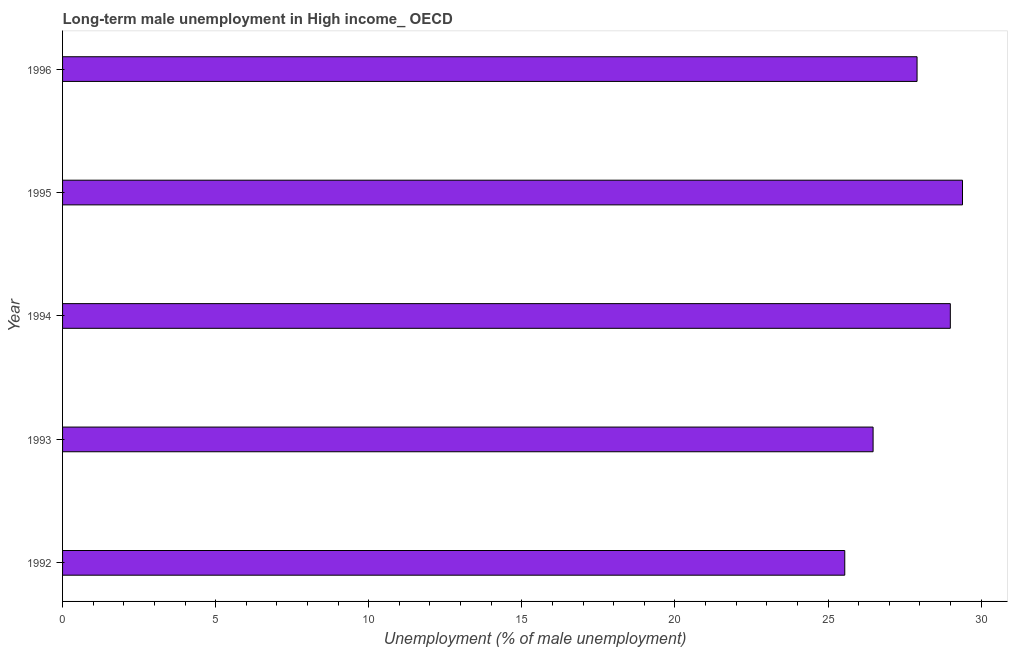What is the title of the graph?
Your response must be concise. Long-term male unemployment in High income_ OECD. What is the label or title of the X-axis?
Provide a succinct answer. Unemployment (% of male unemployment). What is the long-term male unemployment in 1993?
Offer a very short reply. 26.47. Across all years, what is the maximum long-term male unemployment?
Your answer should be compact. 29.39. Across all years, what is the minimum long-term male unemployment?
Give a very brief answer. 25.55. In which year was the long-term male unemployment maximum?
Your response must be concise. 1995. In which year was the long-term male unemployment minimum?
Make the answer very short. 1992. What is the sum of the long-term male unemployment?
Ensure brevity in your answer.  138.31. What is the difference between the long-term male unemployment in 1993 and 1994?
Make the answer very short. -2.52. What is the average long-term male unemployment per year?
Your answer should be very brief. 27.66. What is the median long-term male unemployment?
Offer a terse response. 27.91. Do a majority of the years between 1995 and 1996 (inclusive) have long-term male unemployment greater than 21 %?
Your answer should be compact. Yes. Is the difference between the long-term male unemployment in 1992 and 1996 greater than the difference between any two years?
Ensure brevity in your answer.  No. What is the difference between the highest and the second highest long-term male unemployment?
Offer a very short reply. 0.4. What is the difference between the highest and the lowest long-term male unemployment?
Make the answer very short. 3.85. In how many years, is the long-term male unemployment greater than the average long-term male unemployment taken over all years?
Give a very brief answer. 3. What is the difference between two consecutive major ticks on the X-axis?
Your response must be concise. 5. Are the values on the major ticks of X-axis written in scientific E-notation?
Provide a short and direct response. No. What is the Unemployment (% of male unemployment) of 1992?
Your answer should be very brief. 25.55. What is the Unemployment (% of male unemployment) of 1993?
Keep it short and to the point. 26.47. What is the Unemployment (% of male unemployment) in 1994?
Keep it short and to the point. 28.99. What is the Unemployment (% of male unemployment) of 1995?
Make the answer very short. 29.39. What is the Unemployment (% of male unemployment) in 1996?
Your response must be concise. 27.91. What is the difference between the Unemployment (% of male unemployment) in 1992 and 1993?
Offer a terse response. -0.93. What is the difference between the Unemployment (% of male unemployment) in 1992 and 1994?
Your answer should be very brief. -3.45. What is the difference between the Unemployment (% of male unemployment) in 1992 and 1995?
Your response must be concise. -3.85. What is the difference between the Unemployment (% of male unemployment) in 1992 and 1996?
Keep it short and to the point. -2.36. What is the difference between the Unemployment (% of male unemployment) in 1993 and 1994?
Provide a short and direct response. -2.52. What is the difference between the Unemployment (% of male unemployment) in 1993 and 1995?
Give a very brief answer. -2.92. What is the difference between the Unemployment (% of male unemployment) in 1993 and 1996?
Ensure brevity in your answer.  -1.44. What is the difference between the Unemployment (% of male unemployment) in 1994 and 1995?
Provide a succinct answer. -0.4. What is the difference between the Unemployment (% of male unemployment) in 1994 and 1996?
Your response must be concise. 1.09. What is the difference between the Unemployment (% of male unemployment) in 1995 and 1996?
Provide a succinct answer. 1.48. What is the ratio of the Unemployment (% of male unemployment) in 1992 to that in 1993?
Your answer should be compact. 0.96. What is the ratio of the Unemployment (% of male unemployment) in 1992 to that in 1994?
Your answer should be compact. 0.88. What is the ratio of the Unemployment (% of male unemployment) in 1992 to that in 1995?
Provide a short and direct response. 0.87. What is the ratio of the Unemployment (% of male unemployment) in 1992 to that in 1996?
Provide a succinct answer. 0.92. What is the ratio of the Unemployment (% of male unemployment) in 1993 to that in 1994?
Keep it short and to the point. 0.91. What is the ratio of the Unemployment (% of male unemployment) in 1993 to that in 1995?
Provide a succinct answer. 0.9. What is the ratio of the Unemployment (% of male unemployment) in 1993 to that in 1996?
Make the answer very short. 0.95. What is the ratio of the Unemployment (% of male unemployment) in 1994 to that in 1995?
Provide a succinct answer. 0.99. What is the ratio of the Unemployment (% of male unemployment) in 1994 to that in 1996?
Offer a terse response. 1.04. What is the ratio of the Unemployment (% of male unemployment) in 1995 to that in 1996?
Offer a very short reply. 1.05. 